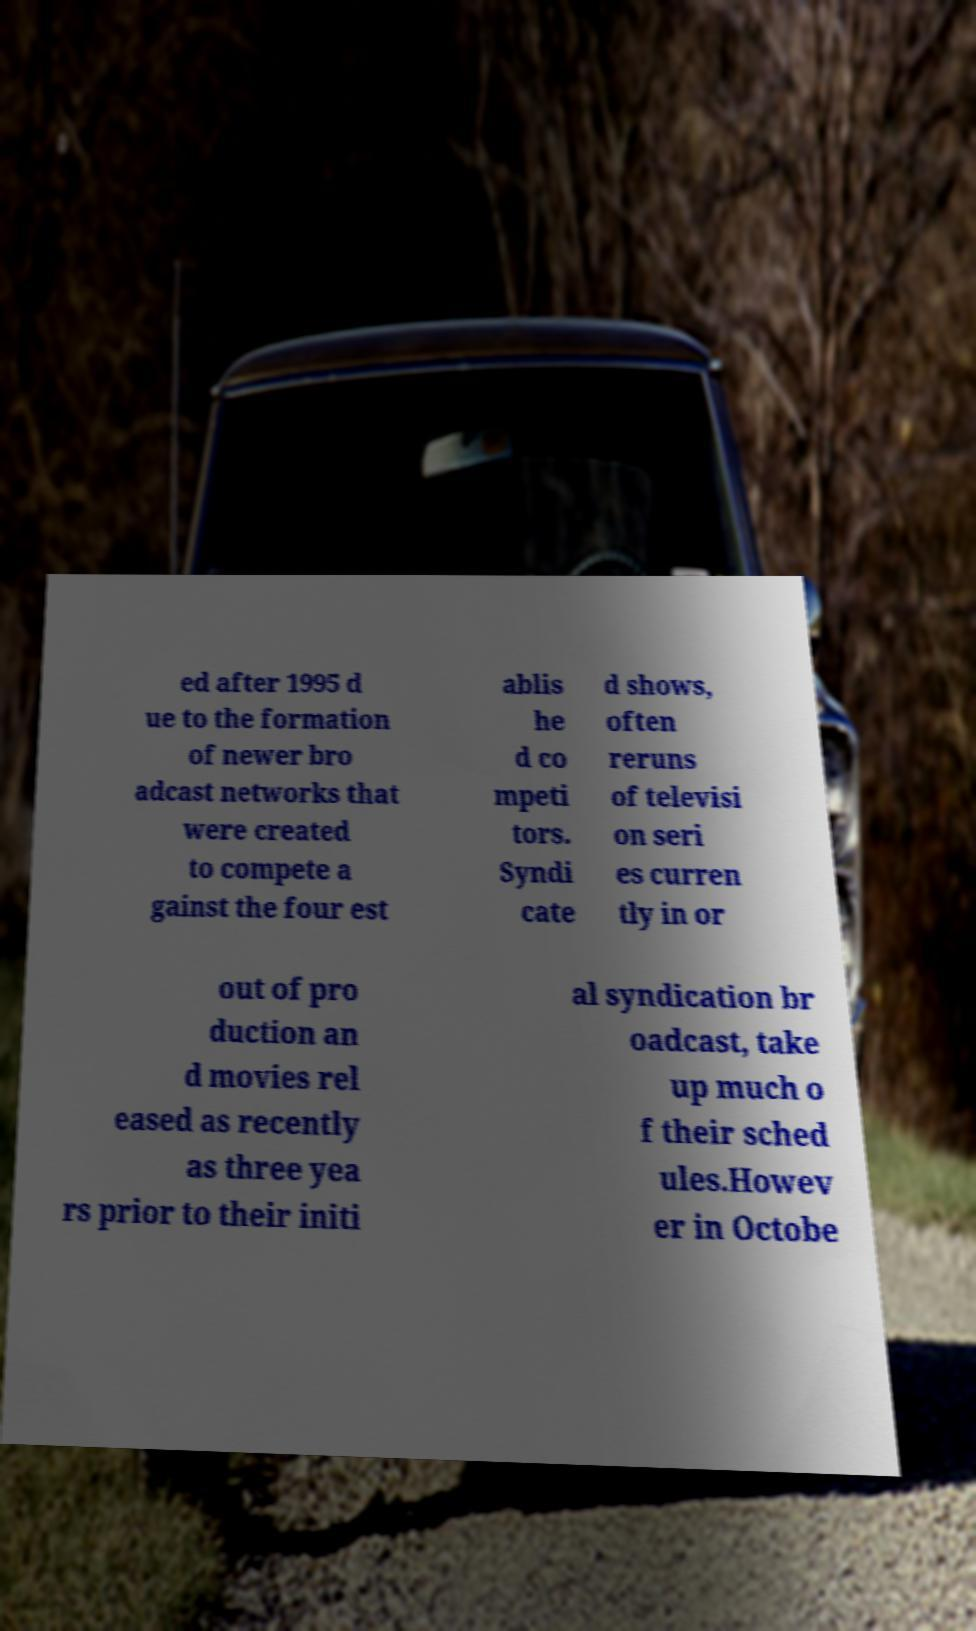There's text embedded in this image that I need extracted. Can you transcribe it verbatim? ed after 1995 d ue to the formation of newer bro adcast networks that were created to compete a gainst the four est ablis he d co mpeti tors. Syndi cate d shows, often reruns of televisi on seri es curren tly in or out of pro duction an d movies rel eased as recently as three yea rs prior to their initi al syndication br oadcast, take up much o f their sched ules.Howev er in Octobe 